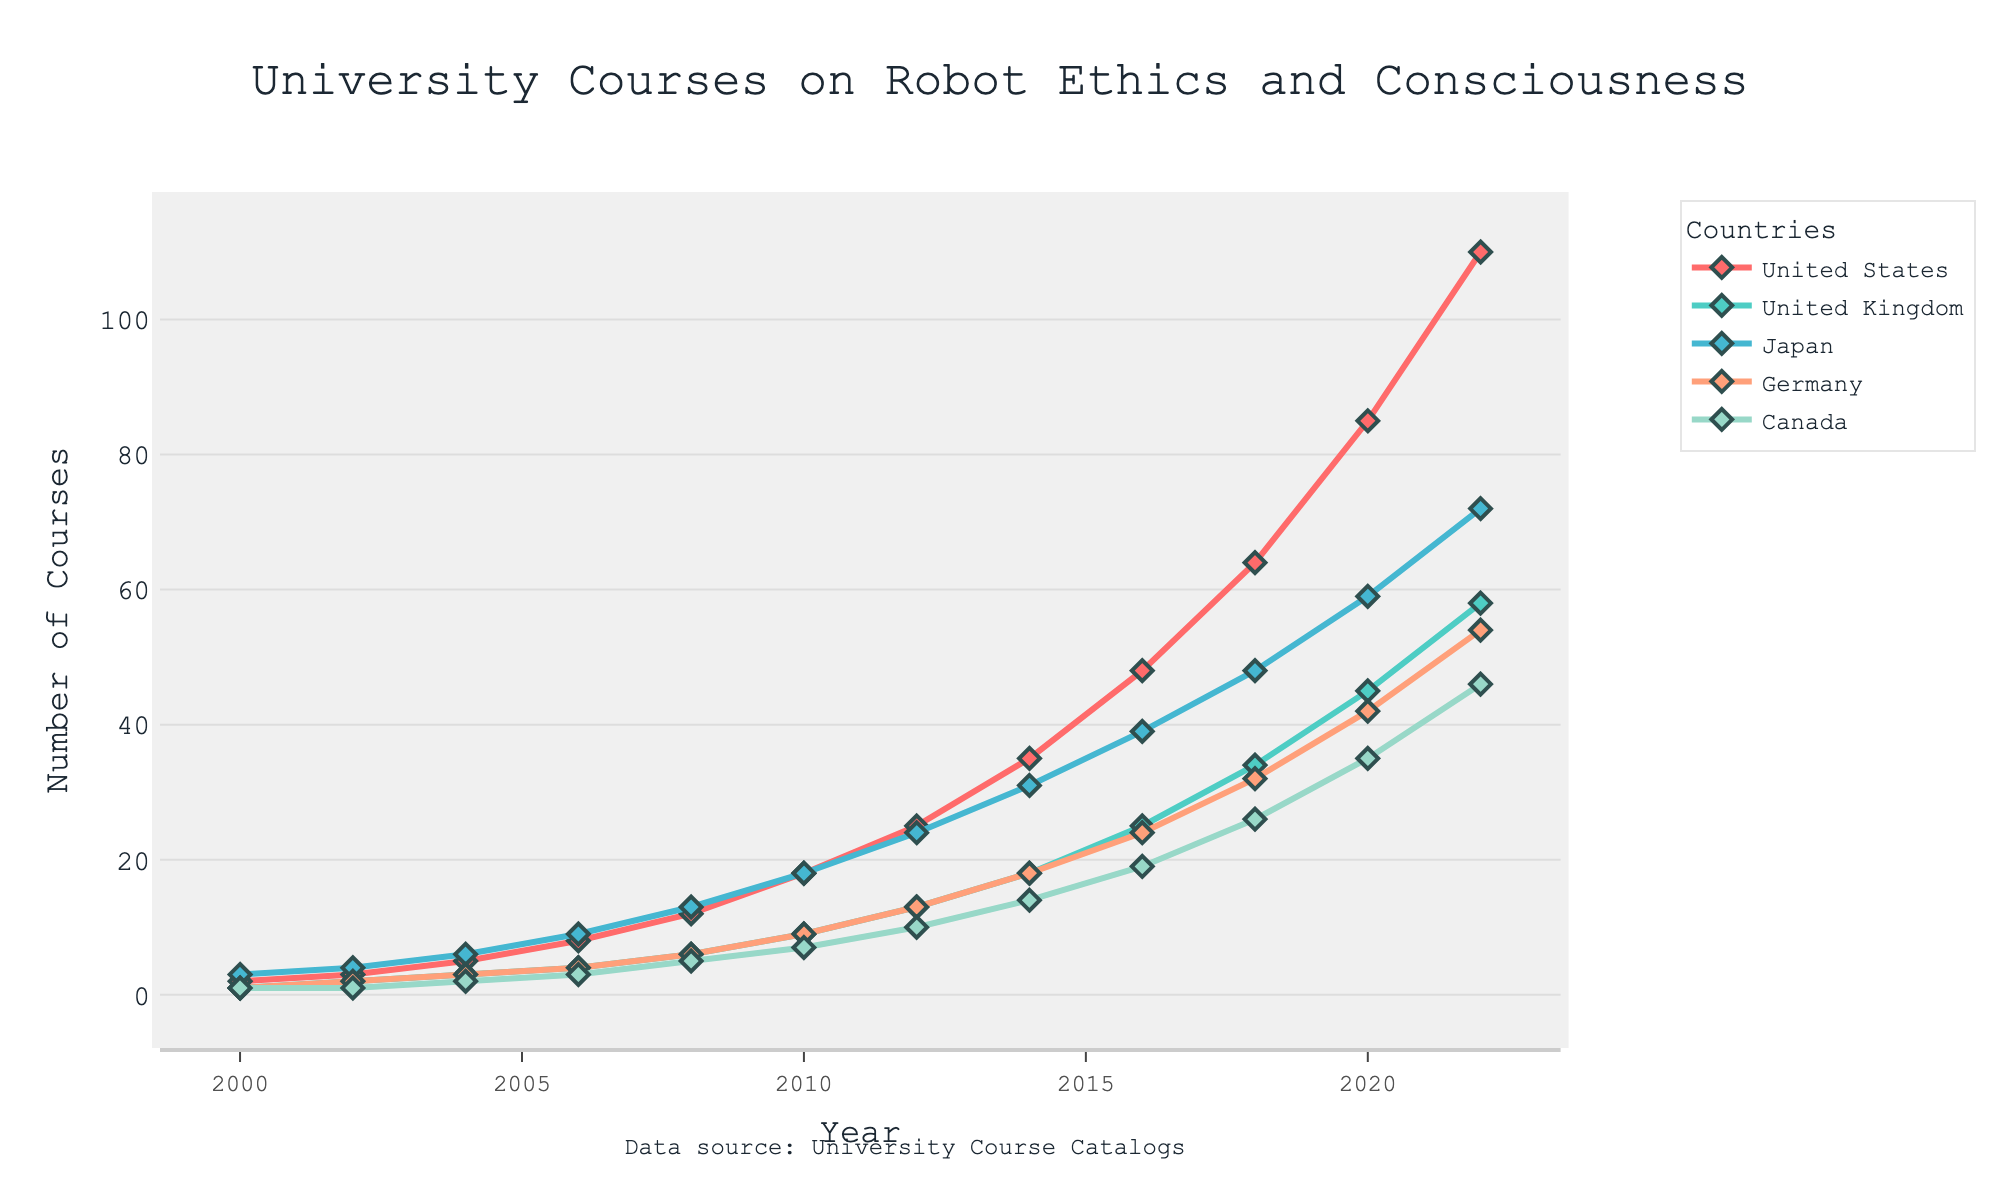What is the general trend in the number of courses offered on robot ethics and consciousness in the United States from 2000 to 2022? The line chart shows an increasing trend with data points starting at 2 in 2000 and rising steadily to 110 in 2022. Each step between years shows a noticeable increase without any decline.
Answer: Increasing How many more courses were offered in Japan compared to Germany in 2020? In 2020, Japan had 59 courses and Germany had 42 courses. The difference is calculated by 59 - 42.
Answer: 17 Which country saw the highest number of courses in 2022, and by how much did it surpass the second highest? In 2022, the United States had the highest number of courses at 110, followed by Japan with 72 courses. The difference is calculated by 110 - 72.
Answer: United States, 38 By how much did the number of courses in Canada increase between 2016 and 2022? In 2016, Canada had 19 courses, and in 2022, it had 46 courses. The increase is calculated by 46 - 19.
Answer: 27 Which year experienced the most significant increase in the number of courses in the United Kingdom? Referring to the data for the United Kingdom, from 2016 (25 courses) to 2018 (34 courses), there was an increase of 34 - 25 = 9 courses. The other incremental changes are smaller.
Answer: 2016 to 2018 What is the total number of courses offered in 2010 across all five countries? Summing the data points for 2010: United States (18) + United Kingdom (9) + Japan (18) + Germany (9) + Canada (7) = 61
Answer: 61 Which country had the slowest initial growth in university courses on robot ethics and consciousness by 2004? By 2004, the United Kingdom had increased from 1 to 3 courses, whereas Canada increased from 1 to 2, and other countries started higher or increased faster.
Answer: Canada How many courses in total were offered by Germany and Canada combined in 2012? In 2012, Germany offered 13 courses, and Canada offered 10 courses. The total is 13 + 10.
Answer: 23 Which country's line was marked in green in the plot? The plot is described to assign colors to the lines, with the United Kingdom assigned a unique color. Visually identifying the data and the color scheme used indicates that the green line corresponds to the United Kingdom.
Answer: United Kingdom 